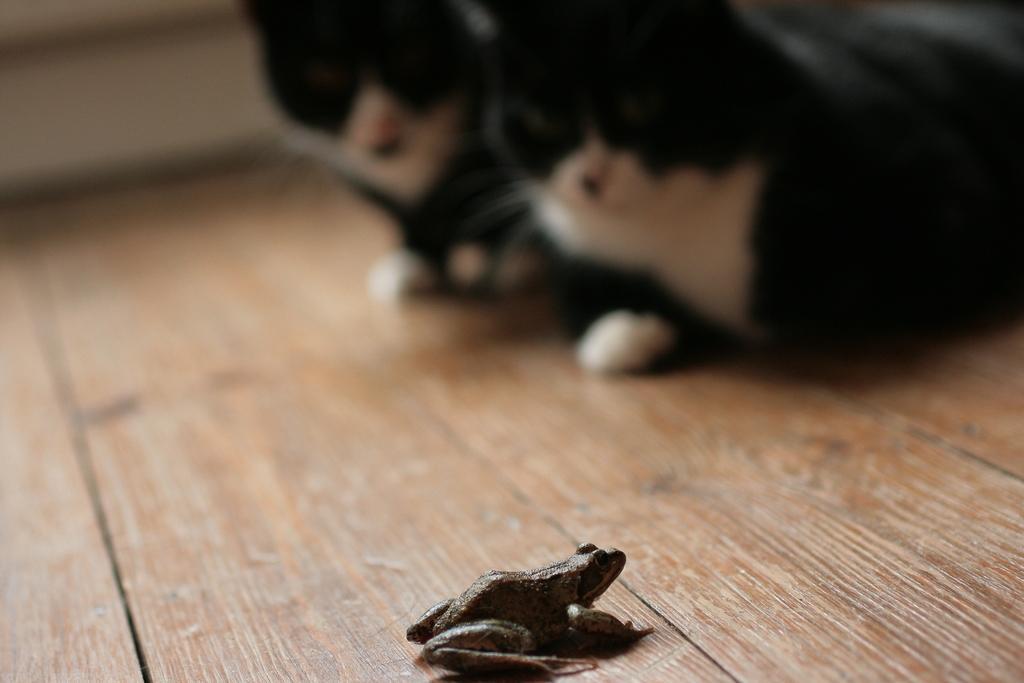In one or two sentences, can you explain what this image depicts? In this picture we can see a frog and two animals on a wooden platform and in the background it is blurry. 